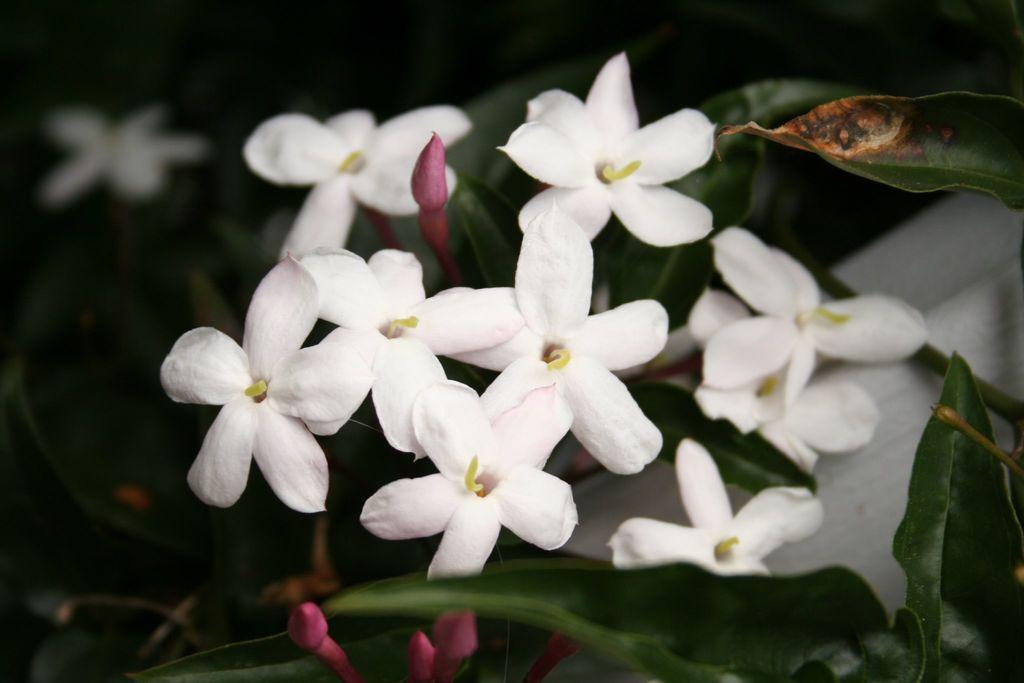What is present in the image? There is a plant in the image. What can be observed about the flowers on the plant? The flowers on the plant have a white color. Is there a guide leading a group of people through a cave in the image? No, there is no guide or cave present in the image; it only features a plant with white flowers. Can you see any toothpaste on the plant in the image? No, there is no toothpaste present in the image; it only features a plant with white flowers. 